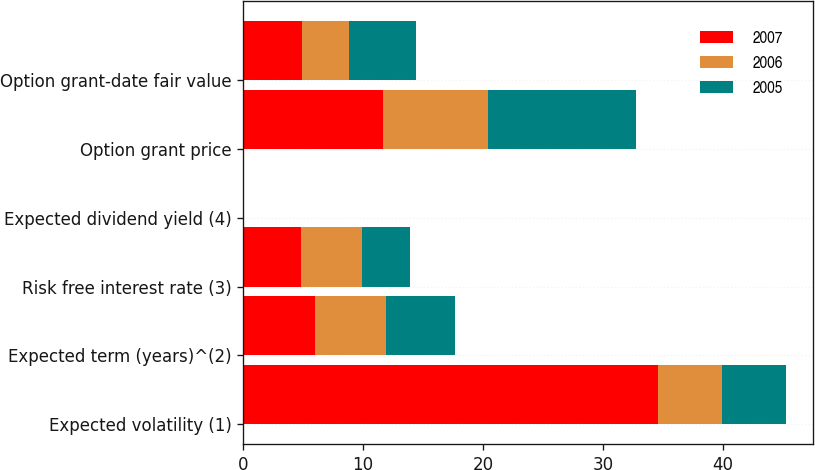Convert chart to OTSL. <chart><loc_0><loc_0><loc_500><loc_500><stacked_bar_chart><ecel><fcel>Expected volatility (1)<fcel>Expected term (years)^(2)<fcel>Risk free interest rate (3)<fcel>Expected dividend yield (4)<fcel>Option grant price<fcel>Option grant-date fair value<nl><fcel>2007<fcel>34.6<fcel>6<fcel>4.8<fcel>0<fcel>11.68<fcel>4.89<nl><fcel>2006<fcel>5.36<fcel>5.9<fcel>5.1<fcel>0<fcel>8.73<fcel>3.91<nl><fcel>2005<fcel>5.36<fcel>5.8<fcel>4<fcel>0<fcel>12.39<fcel>5.62<nl></chart> 